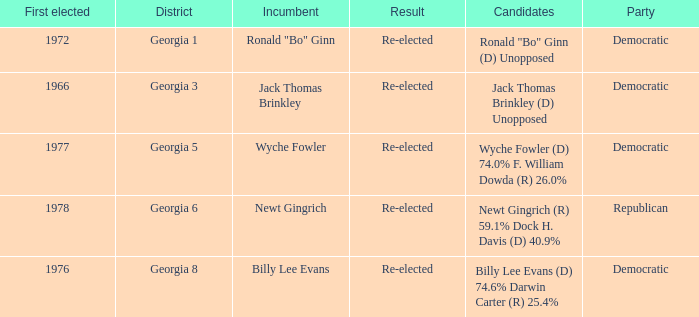What is the party with the candidates newt gingrich (r) 59.1% dock h. davis (d) 40.9%? Republican. 